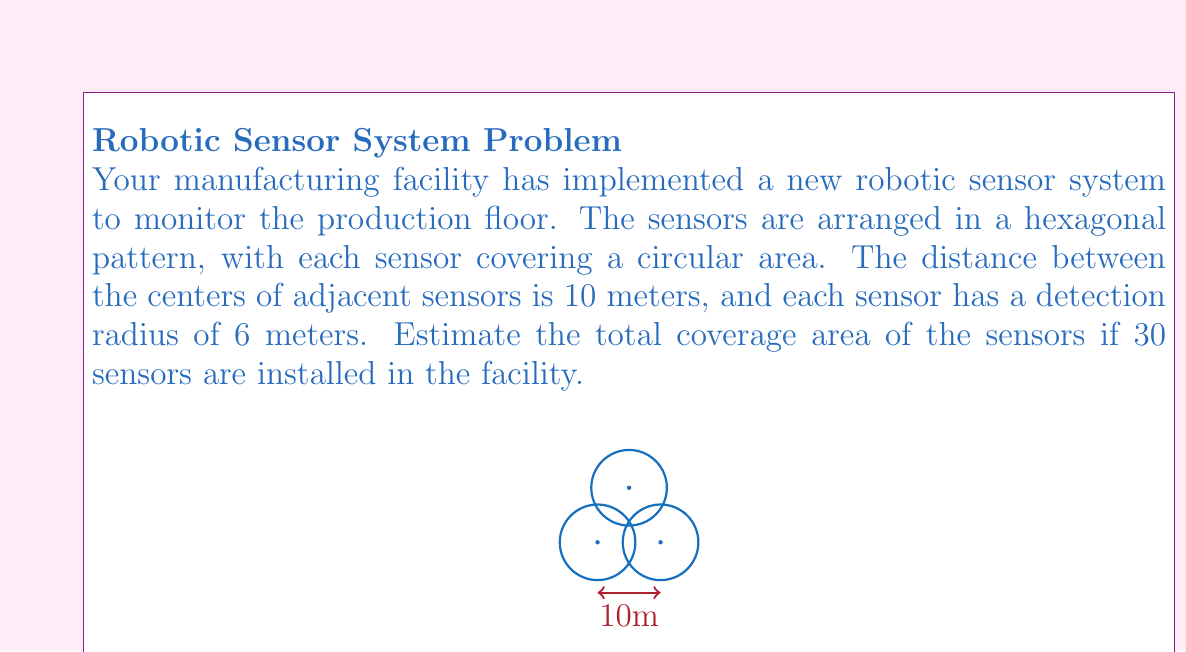Provide a solution to this math problem. To solve this problem, we'll follow these steps:

1) First, we need to calculate the area covered by a single sensor:
   Area of one sensor = $\pi r^2 = \pi (6m)^2 = 36\pi$ m²

2) However, the sensors overlap. To account for this, we can calculate the area of the hexagon formed by the centers of six adjacent sensors:
   Side length of hexagon = 10m
   Area of hexagon = $\frac{3\sqrt{3}}{2}s^2 = \frac{3\sqrt{3}}{2}(10m)^2 = 150\sqrt{3}$ m²

3) This hexagonal area contains the full coverage of one sensor plus partial coverage from six surrounding sensors. We can approximate this as being equivalent to the area of two full sensors:
   Effective coverage per hexagon ≈ $2 * 36\pi$ m² = $72\pi$ m²

4) Now we can calculate the number of hexagons:
   Number of hexagons = Number of sensors / 2 = 30 / 2 = 15

5) Finally, we can estimate the total coverage area:
   Total coverage ≈ 15 * $72\pi$ m² = $1080\pi$ m² ≈ 3393 m²
Answer: Approximately 3393 m² 